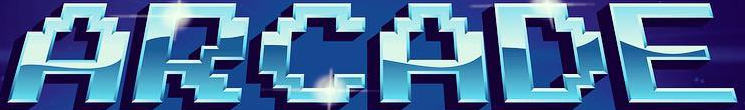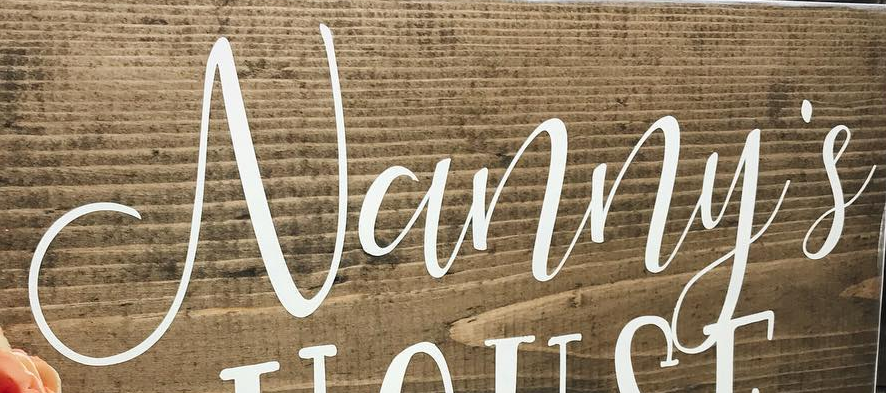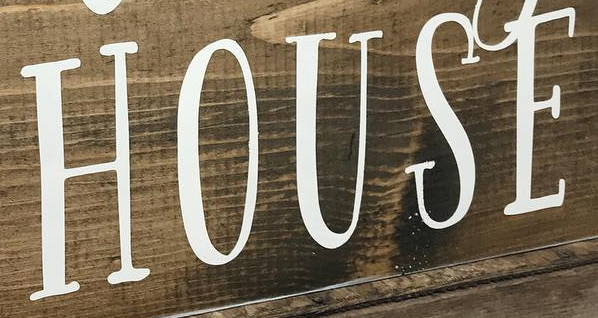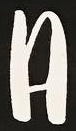What words can you see in these images in sequence, separated by a semicolon? ARCADE; Vanny's; HOUSE; A 